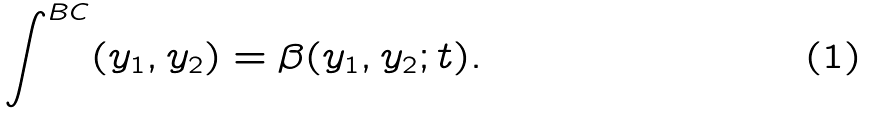Convert formula to latex. <formula><loc_0><loc_0><loc_500><loc_500>\int ^ { B C } ( y _ { 1 } , y _ { 2 } ) = \beta ( y _ { 1 } , y _ { 2 } ; t ) .</formula> 